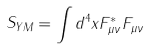<formula> <loc_0><loc_0><loc_500><loc_500>S _ { Y M } = \int d ^ { 4 } x F _ { \mu \nu } ^ { * } F _ { \mu \nu }</formula> 